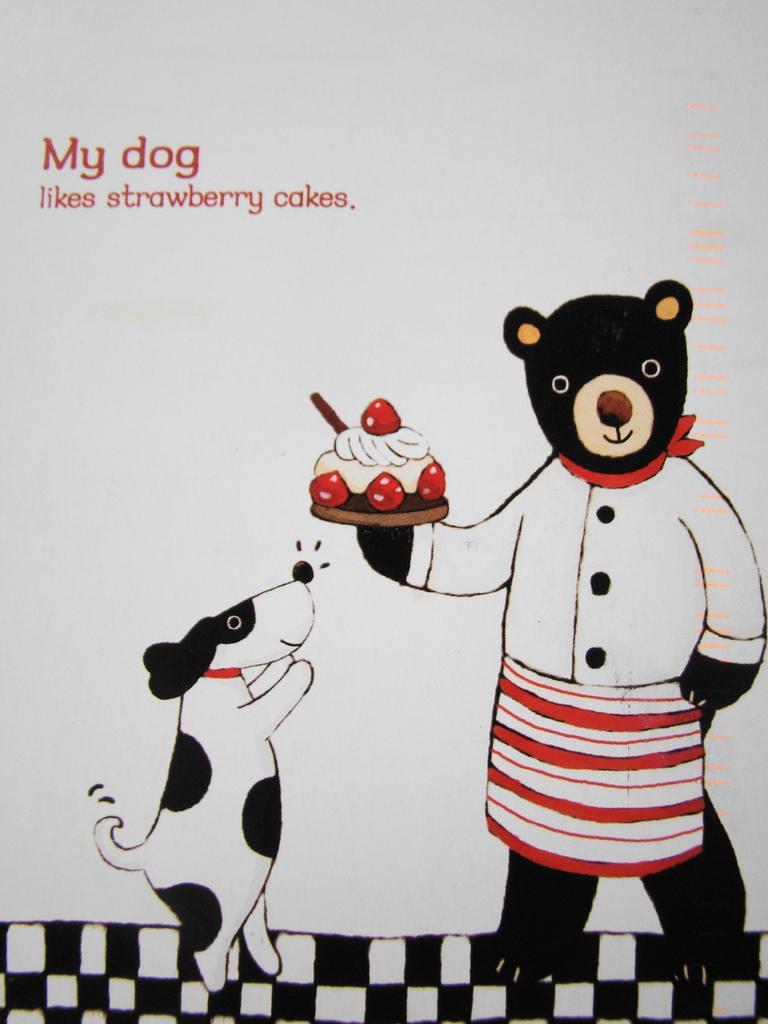Please provide a concise description of this image. In this picture, we see a bear is holding a cake in its hand. Beside that, we see a dog. In the background, it is white in color and we some text written on it. This picture might be taken from the textbook. 